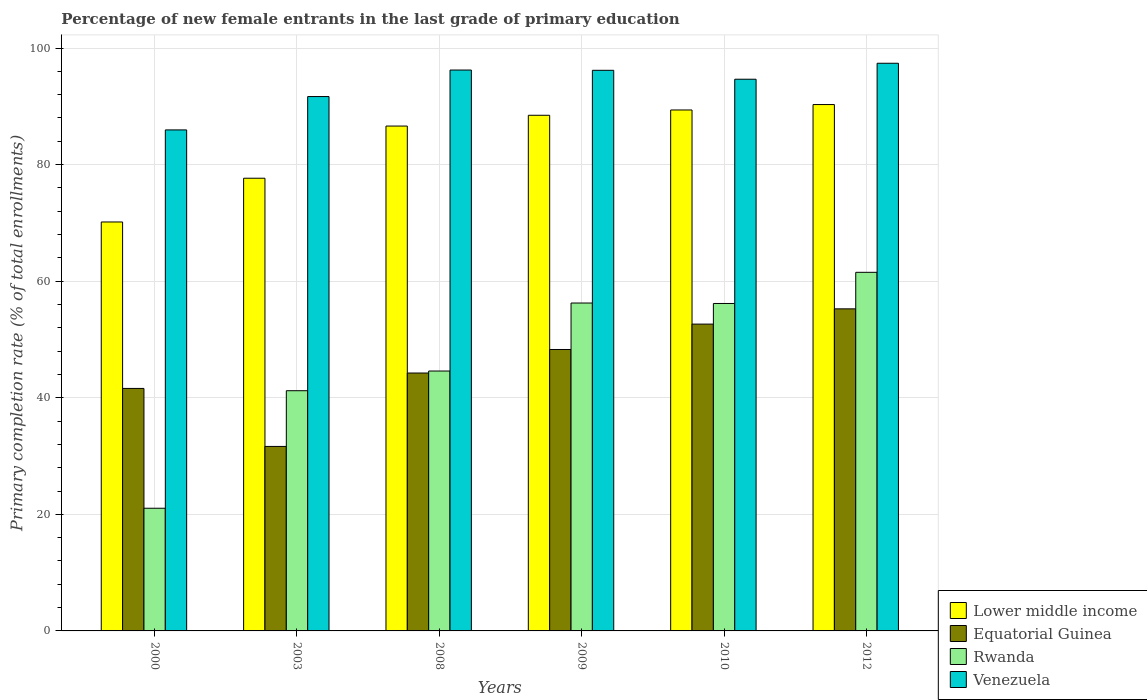How many groups of bars are there?
Offer a very short reply. 6. Are the number of bars on each tick of the X-axis equal?
Your response must be concise. Yes. What is the label of the 6th group of bars from the left?
Keep it short and to the point. 2012. In how many cases, is the number of bars for a given year not equal to the number of legend labels?
Make the answer very short. 0. What is the percentage of new female entrants in Equatorial Guinea in 2008?
Ensure brevity in your answer.  44.24. Across all years, what is the maximum percentage of new female entrants in Venezuela?
Make the answer very short. 97.39. Across all years, what is the minimum percentage of new female entrants in Lower middle income?
Offer a terse response. 70.16. In which year was the percentage of new female entrants in Lower middle income maximum?
Your response must be concise. 2012. In which year was the percentage of new female entrants in Rwanda minimum?
Offer a terse response. 2000. What is the total percentage of new female entrants in Equatorial Guinea in the graph?
Your answer should be very brief. 273.67. What is the difference between the percentage of new female entrants in Rwanda in 2000 and that in 2012?
Give a very brief answer. -40.48. What is the difference between the percentage of new female entrants in Venezuela in 2010 and the percentage of new female entrants in Equatorial Guinea in 2012?
Your answer should be very brief. 39.4. What is the average percentage of new female entrants in Rwanda per year?
Your answer should be very brief. 46.8. In the year 2008, what is the difference between the percentage of new female entrants in Equatorial Guinea and percentage of new female entrants in Lower middle income?
Keep it short and to the point. -42.37. In how many years, is the percentage of new female entrants in Venezuela greater than 80 %?
Provide a short and direct response. 6. What is the ratio of the percentage of new female entrants in Venezuela in 2009 to that in 2012?
Ensure brevity in your answer.  0.99. Is the difference between the percentage of new female entrants in Equatorial Guinea in 2009 and 2012 greater than the difference between the percentage of new female entrants in Lower middle income in 2009 and 2012?
Offer a terse response. No. What is the difference between the highest and the second highest percentage of new female entrants in Equatorial Guinea?
Provide a short and direct response. 2.62. What is the difference between the highest and the lowest percentage of new female entrants in Venezuela?
Make the answer very short. 11.44. In how many years, is the percentage of new female entrants in Venezuela greater than the average percentage of new female entrants in Venezuela taken over all years?
Your answer should be compact. 4. Is the sum of the percentage of new female entrants in Equatorial Guinea in 2008 and 2012 greater than the maximum percentage of new female entrants in Venezuela across all years?
Your answer should be very brief. Yes. What does the 2nd bar from the left in 2009 represents?
Your response must be concise. Equatorial Guinea. What does the 4th bar from the right in 2009 represents?
Offer a very short reply. Lower middle income. How many bars are there?
Provide a short and direct response. 24. Are all the bars in the graph horizontal?
Your answer should be very brief. No. What is the difference between two consecutive major ticks on the Y-axis?
Offer a terse response. 20. Does the graph contain any zero values?
Offer a terse response. No. Where does the legend appear in the graph?
Give a very brief answer. Bottom right. How many legend labels are there?
Offer a very short reply. 4. How are the legend labels stacked?
Offer a very short reply. Vertical. What is the title of the graph?
Your answer should be very brief. Percentage of new female entrants in the last grade of primary education. Does "Burkina Faso" appear as one of the legend labels in the graph?
Provide a short and direct response. No. What is the label or title of the X-axis?
Provide a short and direct response. Years. What is the label or title of the Y-axis?
Your answer should be compact. Primary completion rate (% of total enrollments). What is the Primary completion rate (% of total enrollments) of Lower middle income in 2000?
Keep it short and to the point. 70.16. What is the Primary completion rate (% of total enrollments) in Equatorial Guinea in 2000?
Offer a very short reply. 41.6. What is the Primary completion rate (% of total enrollments) of Rwanda in 2000?
Offer a very short reply. 21.05. What is the Primary completion rate (% of total enrollments) of Venezuela in 2000?
Your response must be concise. 85.95. What is the Primary completion rate (% of total enrollments) in Lower middle income in 2003?
Keep it short and to the point. 77.67. What is the Primary completion rate (% of total enrollments) of Equatorial Guinea in 2003?
Your answer should be compact. 31.65. What is the Primary completion rate (% of total enrollments) of Rwanda in 2003?
Provide a succinct answer. 41.21. What is the Primary completion rate (% of total enrollments) of Venezuela in 2003?
Keep it short and to the point. 91.68. What is the Primary completion rate (% of total enrollments) of Lower middle income in 2008?
Offer a terse response. 86.62. What is the Primary completion rate (% of total enrollments) in Equatorial Guinea in 2008?
Your response must be concise. 44.24. What is the Primary completion rate (% of total enrollments) of Rwanda in 2008?
Ensure brevity in your answer.  44.59. What is the Primary completion rate (% of total enrollments) in Venezuela in 2008?
Offer a terse response. 96.23. What is the Primary completion rate (% of total enrollments) in Lower middle income in 2009?
Offer a very short reply. 88.46. What is the Primary completion rate (% of total enrollments) in Equatorial Guinea in 2009?
Make the answer very short. 48.28. What is the Primary completion rate (% of total enrollments) in Rwanda in 2009?
Keep it short and to the point. 56.25. What is the Primary completion rate (% of total enrollments) of Venezuela in 2009?
Your answer should be compact. 96.18. What is the Primary completion rate (% of total enrollments) in Lower middle income in 2010?
Give a very brief answer. 89.37. What is the Primary completion rate (% of total enrollments) in Equatorial Guinea in 2010?
Keep it short and to the point. 52.64. What is the Primary completion rate (% of total enrollments) in Rwanda in 2010?
Your answer should be compact. 56.18. What is the Primary completion rate (% of total enrollments) in Venezuela in 2010?
Your response must be concise. 94.65. What is the Primary completion rate (% of total enrollments) of Lower middle income in 2012?
Give a very brief answer. 90.3. What is the Primary completion rate (% of total enrollments) in Equatorial Guinea in 2012?
Offer a very short reply. 55.26. What is the Primary completion rate (% of total enrollments) in Rwanda in 2012?
Offer a very short reply. 61.52. What is the Primary completion rate (% of total enrollments) of Venezuela in 2012?
Offer a terse response. 97.39. Across all years, what is the maximum Primary completion rate (% of total enrollments) in Lower middle income?
Provide a succinct answer. 90.3. Across all years, what is the maximum Primary completion rate (% of total enrollments) in Equatorial Guinea?
Provide a succinct answer. 55.26. Across all years, what is the maximum Primary completion rate (% of total enrollments) of Rwanda?
Your answer should be compact. 61.52. Across all years, what is the maximum Primary completion rate (% of total enrollments) of Venezuela?
Make the answer very short. 97.39. Across all years, what is the minimum Primary completion rate (% of total enrollments) in Lower middle income?
Your answer should be very brief. 70.16. Across all years, what is the minimum Primary completion rate (% of total enrollments) of Equatorial Guinea?
Offer a terse response. 31.65. Across all years, what is the minimum Primary completion rate (% of total enrollments) in Rwanda?
Ensure brevity in your answer.  21.05. Across all years, what is the minimum Primary completion rate (% of total enrollments) of Venezuela?
Make the answer very short. 85.95. What is the total Primary completion rate (% of total enrollments) of Lower middle income in the graph?
Offer a very short reply. 502.59. What is the total Primary completion rate (% of total enrollments) in Equatorial Guinea in the graph?
Provide a short and direct response. 273.67. What is the total Primary completion rate (% of total enrollments) in Rwanda in the graph?
Keep it short and to the point. 280.8. What is the total Primary completion rate (% of total enrollments) in Venezuela in the graph?
Give a very brief answer. 562.08. What is the difference between the Primary completion rate (% of total enrollments) of Lower middle income in 2000 and that in 2003?
Ensure brevity in your answer.  -7.51. What is the difference between the Primary completion rate (% of total enrollments) in Equatorial Guinea in 2000 and that in 2003?
Give a very brief answer. 9.95. What is the difference between the Primary completion rate (% of total enrollments) in Rwanda in 2000 and that in 2003?
Offer a very short reply. -20.16. What is the difference between the Primary completion rate (% of total enrollments) of Venezuela in 2000 and that in 2003?
Keep it short and to the point. -5.72. What is the difference between the Primary completion rate (% of total enrollments) of Lower middle income in 2000 and that in 2008?
Provide a short and direct response. -16.46. What is the difference between the Primary completion rate (% of total enrollments) in Equatorial Guinea in 2000 and that in 2008?
Your response must be concise. -2.64. What is the difference between the Primary completion rate (% of total enrollments) of Rwanda in 2000 and that in 2008?
Make the answer very short. -23.54. What is the difference between the Primary completion rate (% of total enrollments) of Venezuela in 2000 and that in 2008?
Keep it short and to the point. -10.27. What is the difference between the Primary completion rate (% of total enrollments) in Lower middle income in 2000 and that in 2009?
Offer a terse response. -18.3. What is the difference between the Primary completion rate (% of total enrollments) in Equatorial Guinea in 2000 and that in 2009?
Offer a terse response. -6.68. What is the difference between the Primary completion rate (% of total enrollments) in Rwanda in 2000 and that in 2009?
Provide a short and direct response. -35.21. What is the difference between the Primary completion rate (% of total enrollments) in Venezuela in 2000 and that in 2009?
Make the answer very short. -10.23. What is the difference between the Primary completion rate (% of total enrollments) of Lower middle income in 2000 and that in 2010?
Keep it short and to the point. -19.21. What is the difference between the Primary completion rate (% of total enrollments) in Equatorial Guinea in 2000 and that in 2010?
Ensure brevity in your answer.  -11.04. What is the difference between the Primary completion rate (% of total enrollments) in Rwanda in 2000 and that in 2010?
Ensure brevity in your answer.  -35.13. What is the difference between the Primary completion rate (% of total enrollments) of Venezuela in 2000 and that in 2010?
Keep it short and to the point. -8.7. What is the difference between the Primary completion rate (% of total enrollments) of Lower middle income in 2000 and that in 2012?
Ensure brevity in your answer.  -20.14. What is the difference between the Primary completion rate (% of total enrollments) of Equatorial Guinea in 2000 and that in 2012?
Ensure brevity in your answer.  -13.65. What is the difference between the Primary completion rate (% of total enrollments) in Rwanda in 2000 and that in 2012?
Provide a short and direct response. -40.48. What is the difference between the Primary completion rate (% of total enrollments) in Venezuela in 2000 and that in 2012?
Make the answer very short. -11.44. What is the difference between the Primary completion rate (% of total enrollments) of Lower middle income in 2003 and that in 2008?
Offer a terse response. -8.95. What is the difference between the Primary completion rate (% of total enrollments) of Equatorial Guinea in 2003 and that in 2008?
Make the answer very short. -12.59. What is the difference between the Primary completion rate (% of total enrollments) of Rwanda in 2003 and that in 2008?
Offer a very short reply. -3.38. What is the difference between the Primary completion rate (% of total enrollments) of Venezuela in 2003 and that in 2008?
Your response must be concise. -4.55. What is the difference between the Primary completion rate (% of total enrollments) in Lower middle income in 2003 and that in 2009?
Provide a short and direct response. -10.8. What is the difference between the Primary completion rate (% of total enrollments) of Equatorial Guinea in 2003 and that in 2009?
Ensure brevity in your answer.  -16.63. What is the difference between the Primary completion rate (% of total enrollments) of Rwanda in 2003 and that in 2009?
Ensure brevity in your answer.  -15.04. What is the difference between the Primary completion rate (% of total enrollments) of Venezuela in 2003 and that in 2009?
Give a very brief answer. -4.51. What is the difference between the Primary completion rate (% of total enrollments) in Lower middle income in 2003 and that in 2010?
Offer a very short reply. -11.71. What is the difference between the Primary completion rate (% of total enrollments) of Equatorial Guinea in 2003 and that in 2010?
Offer a very short reply. -20.99. What is the difference between the Primary completion rate (% of total enrollments) of Rwanda in 2003 and that in 2010?
Provide a short and direct response. -14.97. What is the difference between the Primary completion rate (% of total enrollments) of Venezuela in 2003 and that in 2010?
Provide a succinct answer. -2.98. What is the difference between the Primary completion rate (% of total enrollments) in Lower middle income in 2003 and that in 2012?
Offer a very short reply. -12.64. What is the difference between the Primary completion rate (% of total enrollments) in Equatorial Guinea in 2003 and that in 2012?
Your response must be concise. -23.6. What is the difference between the Primary completion rate (% of total enrollments) of Rwanda in 2003 and that in 2012?
Ensure brevity in your answer.  -20.31. What is the difference between the Primary completion rate (% of total enrollments) of Venezuela in 2003 and that in 2012?
Make the answer very short. -5.71. What is the difference between the Primary completion rate (% of total enrollments) of Lower middle income in 2008 and that in 2009?
Give a very brief answer. -1.85. What is the difference between the Primary completion rate (% of total enrollments) of Equatorial Guinea in 2008 and that in 2009?
Your answer should be very brief. -4.04. What is the difference between the Primary completion rate (% of total enrollments) in Rwanda in 2008 and that in 2009?
Your response must be concise. -11.67. What is the difference between the Primary completion rate (% of total enrollments) in Venezuela in 2008 and that in 2009?
Your answer should be very brief. 0.04. What is the difference between the Primary completion rate (% of total enrollments) of Lower middle income in 2008 and that in 2010?
Offer a terse response. -2.76. What is the difference between the Primary completion rate (% of total enrollments) of Equatorial Guinea in 2008 and that in 2010?
Your answer should be very brief. -8.39. What is the difference between the Primary completion rate (% of total enrollments) in Rwanda in 2008 and that in 2010?
Keep it short and to the point. -11.59. What is the difference between the Primary completion rate (% of total enrollments) of Venezuela in 2008 and that in 2010?
Keep it short and to the point. 1.57. What is the difference between the Primary completion rate (% of total enrollments) of Lower middle income in 2008 and that in 2012?
Provide a short and direct response. -3.69. What is the difference between the Primary completion rate (% of total enrollments) in Equatorial Guinea in 2008 and that in 2012?
Your answer should be compact. -11.01. What is the difference between the Primary completion rate (% of total enrollments) in Rwanda in 2008 and that in 2012?
Give a very brief answer. -16.93. What is the difference between the Primary completion rate (% of total enrollments) of Venezuela in 2008 and that in 2012?
Keep it short and to the point. -1.16. What is the difference between the Primary completion rate (% of total enrollments) of Lower middle income in 2009 and that in 2010?
Give a very brief answer. -0.91. What is the difference between the Primary completion rate (% of total enrollments) in Equatorial Guinea in 2009 and that in 2010?
Offer a very short reply. -4.36. What is the difference between the Primary completion rate (% of total enrollments) in Rwanda in 2009 and that in 2010?
Keep it short and to the point. 0.08. What is the difference between the Primary completion rate (% of total enrollments) in Venezuela in 2009 and that in 2010?
Keep it short and to the point. 1.53. What is the difference between the Primary completion rate (% of total enrollments) of Lower middle income in 2009 and that in 2012?
Give a very brief answer. -1.84. What is the difference between the Primary completion rate (% of total enrollments) in Equatorial Guinea in 2009 and that in 2012?
Give a very brief answer. -6.97. What is the difference between the Primary completion rate (% of total enrollments) in Rwanda in 2009 and that in 2012?
Make the answer very short. -5.27. What is the difference between the Primary completion rate (% of total enrollments) of Venezuela in 2009 and that in 2012?
Offer a terse response. -1.21. What is the difference between the Primary completion rate (% of total enrollments) of Lower middle income in 2010 and that in 2012?
Your answer should be compact. -0.93. What is the difference between the Primary completion rate (% of total enrollments) of Equatorial Guinea in 2010 and that in 2012?
Give a very brief answer. -2.62. What is the difference between the Primary completion rate (% of total enrollments) in Rwanda in 2010 and that in 2012?
Your answer should be compact. -5.35. What is the difference between the Primary completion rate (% of total enrollments) of Venezuela in 2010 and that in 2012?
Make the answer very short. -2.74. What is the difference between the Primary completion rate (% of total enrollments) in Lower middle income in 2000 and the Primary completion rate (% of total enrollments) in Equatorial Guinea in 2003?
Give a very brief answer. 38.51. What is the difference between the Primary completion rate (% of total enrollments) in Lower middle income in 2000 and the Primary completion rate (% of total enrollments) in Rwanda in 2003?
Provide a short and direct response. 28.95. What is the difference between the Primary completion rate (% of total enrollments) in Lower middle income in 2000 and the Primary completion rate (% of total enrollments) in Venezuela in 2003?
Your response must be concise. -21.52. What is the difference between the Primary completion rate (% of total enrollments) in Equatorial Guinea in 2000 and the Primary completion rate (% of total enrollments) in Rwanda in 2003?
Make the answer very short. 0.39. What is the difference between the Primary completion rate (% of total enrollments) of Equatorial Guinea in 2000 and the Primary completion rate (% of total enrollments) of Venezuela in 2003?
Provide a short and direct response. -50.07. What is the difference between the Primary completion rate (% of total enrollments) of Rwanda in 2000 and the Primary completion rate (% of total enrollments) of Venezuela in 2003?
Ensure brevity in your answer.  -70.63. What is the difference between the Primary completion rate (% of total enrollments) of Lower middle income in 2000 and the Primary completion rate (% of total enrollments) of Equatorial Guinea in 2008?
Ensure brevity in your answer.  25.92. What is the difference between the Primary completion rate (% of total enrollments) of Lower middle income in 2000 and the Primary completion rate (% of total enrollments) of Rwanda in 2008?
Your response must be concise. 25.57. What is the difference between the Primary completion rate (% of total enrollments) in Lower middle income in 2000 and the Primary completion rate (% of total enrollments) in Venezuela in 2008?
Make the answer very short. -26.06. What is the difference between the Primary completion rate (% of total enrollments) in Equatorial Guinea in 2000 and the Primary completion rate (% of total enrollments) in Rwanda in 2008?
Keep it short and to the point. -2.99. What is the difference between the Primary completion rate (% of total enrollments) in Equatorial Guinea in 2000 and the Primary completion rate (% of total enrollments) in Venezuela in 2008?
Your answer should be very brief. -54.62. What is the difference between the Primary completion rate (% of total enrollments) in Rwanda in 2000 and the Primary completion rate (% of total enrollments) in Venezuela in 2008?
Offer a terse response. -75.18. What is the difference between the Primary completion rate (% of total enrollments) of Lower middle income in 2000 and the Primary completion rate (% of total enrollments) of Equatorial Guinea in 2009?
Give a very brief answer. 21.88. What is the difference between the Primary completion rate (% of total enrollments) of Lower middle income in 2000 and the Primary completion rate (% of total enrollments) of Rwanda in 2009?
Provide a short and direct response. 13.91. What is the difference between the Primary completion rate (% of total enrollments) in Lower middle income in 2000 and the Primary completion rate (% of total enrollments) in Venezuela in 2009?
Keep it short and to the point. -26.02. What is the difference between the Primary completion rate (% of total enrollments) in Equatorial Guinea in 2000 and the Primary completion rate (% of total enrollments) in Rwanda in 2009?
Provide a succinct answer. -14.65. What is the difference between the Primary completion rate (% of total enrollments) of Equatorial Guinea in 2000 and the Primary completion rate (% of total enrollments) of Venezuela in 2009?
Offer a terse response. -54.58. What is the difference between the Primary completion rate (% of total enrollments) of Rwanda in 2000 and the Primary completion rate (% of total enrollments) of Venezuela in 2009?
Offer a terse response. -75.13. What is the difference between the Primary completion rate (% of total enrollments) in Lower middle income in 2000 and the Primary completion rate (% of total enrollments) in Equatorial Guinea in 2010?
Your response must be concise. 17.52. What is the difference between the Primary completion rate (% of total enrollments) of Lower middle income in 2000 and the Primary completion rate (% of total enrollments) of Rwanda in 2010?
Ensure brevity in your answer.  13.98. What is the difference between the Primary completion rate (% of total enrollments) of Lower middle income in 2000 and the Primary completion rate (% of total enrollments) of Venezuela in 2010?
Offer a very short reply. -24.49. What is the difference between the Primary completion rate (% of total enrollments) in Equatorial Guinea in 2000 and the Primary completion rate (% of total enrollments) in Rwanda in 2010?
Keep it short and to the point. -14.58. What is the difference between the Primary completion rate (% of total enrollments) of Equatorial Guinea in 2000 and the Primary completion rate (% of total enrollments) of Venezuela in 2010?
Your answer should be very brief. -53.05. What is the difference between the Primary completion rate (% of total enrollments) of Rwanda in 2000 and the Primary completion rate (% of total enrollments) of Venezuela in 2010?
Make the answer very short. -73.6. What is the difference between the Primary completion rate (% of total enrollments) of Lower middle income in 2000 and the Primary completion rate (% of total enrollments) of Equatorial Guinea in 2012?
Your answer should be compact. 14.91. What is the difference between the Primary completion rate (% of total enrollments) in Lower middle income in 2000 and the Primary completion rate (% of total enrollments) in Rwanda in 2012?
Give a very brief answer. 8.64. What is the difference between the Primary completion rate (% of total enrollments) in Lower middle income in 2000 and the Primary completion rate (% of total enrollments) in Venezuela in 2012?
Your answer should be compact. -27.23. What is the difference between the Primary completion rate (% of total enrollments) of Equatorial Guinea in 2000 and the Primary completion rate (% of total enrollments) of Rwanda in 2012?
Offer a very short reply. -19.92. What is the difference between the Primary completion rate (% of total enrollments) in Equatorial Guinea in 2000 and the Primary completion rate (% of total enrollments) in Venezuela in 2012?
Offer a very short reply. -55.79. What is the difference between the Primary completion rate (% of total enrollments) of Rwanda in 2000 and the Primary completion rate (% of total enrollments) of Venezuela in 2012?
Your answer should be compact. -76.34. What is the difference between the Primary completion rate (% of total enrollments) of Lower middle income in 2003 and the Primary completion rate (% of total enrollments) of Equatorial Guinea in 2008?
Ensure brevity in your answer.  33.42. What is the difference between the Primary completion rate (% of total enrollments) of Lower middle income in 2003 and the Primary completion rate (% of total enrollments) of Rwanda in 2008?
Offer a terse response. 33.08. What is the difference between the Primary completion rate (% of total enrollments) in Lower middle income in 2003 and the Primary completion rate (% of total enrollments) in Venezuela in 2008?
Offer a very short reply. -18.56. What is the difference between the Primary completion rate (% of total enrollments) in Equatorial Guinea in 2003 and the Primary completion rate (% of total enrollments) in Rwanda in 2008?
Offer a very short reply. -12.94. What is the difference between the Primary completion rate (% of total enrollments) of Equatorial Guinea in 2003 and the Primary completion rate (% of total enrollments) of Venezuela in 2008?
Provide a succinct answer. -64.57. What is the difference between the Primary completion rate (% of total enrollments) in Rwanda in 2003 and the Primary completion rate (% of total enrollments) in Venezuela in 2008?
Ensure brevity in your answer.  -55.02. What is the difference between the Primary completion rate (% of total enrollments) in Lower middle income in 2003 and the Primary completion rate (% of total enrollments) in Equatorial Guinea in 2009?
Your response must be concise. 29.38. What is the difference between the Primary completion rate (% of total enrollments) of Lower middle income in 2003 and the Primary completion rate (% of total enrollments) of Rwanda in 2009?
Make the answer very short. 21.41. What is the difference between the Primary completion rate (% of total enrollments) in Lower middle income in 2003 and the Primary completion rate (% of total enrollments) in Venezuela in 2009?
Give a very brief answer. -18.52. What is the difference between the Primary completion rate (% of total enrollments) of Equatorial Guinea in 2003 and the Primary completion rate (% of total enrollments) of Rwanda in 2009?
Keep it short and to the point. -24.6. What is the difference between the Primary completion rate (% of total enrollments) in Equatorial Guinea in 2003 and the Primary completion rate (% of total enrollments) in Venezuela in 2009?
Give a very brief answer. -64.53. What is the difference between the Primary completion rate (% of total enrollments) in Rwanda in 2003 and the Primary completion rate (% of total enrollments) in Venezuela in 2009?
Offer a very short reply. -54.97. What is the difference between the Primary completion rate (% of total enrollments) of Lower middle income in 2003 and the Primary completion rate (% of total enrollments) of Equatorial Guinea in 2010?
Offer a terse response. 25.03. What is the difference between the Primary completion rate (% of total enrollments) of Lower middle income in 2003 and the Primary completion rate (% of total enrollments) of Rwanda in 2010?
Provide a short and direct response. 21.49. What is the difference between the Primary completion rate (% of total enrollments) in Lower middle income in 2003 and the Primary completion rate (% of total enrollments) in Venezuela in 2010?
Provide a short and direct response. -16.99. What is the difference between the Primary completion rate (% of total enrollments) of Equatorial Guinea in 2003 and the Primary completion rate (% of total enrollments) of Rwanda in 2010?
Provide a short and direct response. -24.53. What is the difference between the Primary completion rate (% of total enrollments) of Equatorial Guinea in 2003 and the Primary completion rate (% of total enrollments) of Venezuela in 2010?
Your response must be concise. -63. What is the difference between the Primary completion rate (% of total enrollments) in Rwanda in 2003 and the Primary completion rate (% of total enrollments) in Venezuela in 2010?
Give a very brief answer. -53.44. What is the difference between the Primary completion rate (% of total enrollments) in Lower middle income in 2003 and the Primary completion rate (% of total enrollments) in Equatorial Guinea in 2012?
Your answer should be very brief. 22.41. What is the difference between the Primary completion rate (% of total enrollments) in Lower middle income in 2003 and the Primary completion rate (% of total enrollments) in Rwanda in 2012?
Give a very brief answer. 16.14. What is the difference between the Primary completion rate (% of total enrollments) of Lower middle income in 2003 and the Primary completion rate (% of total enrollments) of Venezuela in 2012?
Offer a very short reply. -19.72. What is the difference between the Primary completion rate (% of total enrollments) in Equatorial Guinea in 2003 and the Primary completion rate (% of total enrollments) in Rwanda in 2012?
Your answer should be compact. -29.87. What is the difference between the Primary completion rate (% of total enrollments) of Equatorial Guinea in 2003 and the Primary completion rate (% of total enrollments) of Venezuela in 2012?
Make the answer very short. -65.74. What is the difference between the Primary completion rate (% of total enrollments) of Rwanda in 2003 and the Primary completion rate (% of total enrollments) of Venezuela in 2012?
Give a very brief answer. -56.18. What is the difference between the Primary completion rate (% of total enrollments) of Lower middle income in 2008 and the Primary completion rate (% of total enrollments) of Equatorial Guinea in 2009?
Provide a short and direct response. 38.34. What is the difference between the Primary completion rate (% of total enrollments) in Lower middle income in 2008 and the Primary completion rate (% of total enrollments) in Rwanda in 2009?
Your answer should be compact. 30.36. What is the difference between the Primary completion rate (% of total enrollments) of Lower middle income in 2008 and the Primary completion rate (% of total enrollments) of Venezuela in 2009?
Keep it short and to the point. -9.56. What is the difference between the Primary completion rate (% of total enrollments) in Equatorial Guinea in 2008 and the Primary completion rate (% of total enrollments) in Rwanda in 2009?
Make the answer very short. -12.01. What is the difference between the Primary completion rate (% of total enrollments) of Equatorial Guinea in 2008 and the Primary completion rate (% of total enrollments) of Venezuela in 2009?
Provide a short and direct response. -51.94. What is the difference between the Primary completion rate (% of total enrollments) of Rwanda in 2008 and the Primary completion rate (% of total enrollments) of Venezuela in 2009?
Your response must be concise. -51.59. What is the difference between the Primary completion rate (% of total enrollments) of Lower middle income in 2008 and the Primary completion rate (% of total enrollments) of Equatorial Guinea in 2010?
Your answer should be very brief. 33.98. What is the difference between the Primary completion rate (% of total enrollments) in Lower middle income in 2008 and the Primary completion rate (% of total enrollments) in Rwanda in 2010?
Your answer should be very brief. 30.44. What is the difference between the Primary completion rate (% of total enrollments) of Lower middle income in 2008 and the Primary completion rate (% of total enrollments) of Venezuela in 2010?
Make the answer very short. -8.03. What is the difference between the Primary completion rate (% of total enrollments) in Equatorial Guinea in 2008 and the Primary completion rate (% of total enrollments) in Rwanda in 2010?
Your answer should be compact. -11.93. What is the difference between the Primary completion rate (% of total enrollments) in Equatorial Guinea in 2008 and the Primary completion rate (% of total enrollments) in Venezuela in 2010?
Keep it short and to the point. -50.41. What is the difference between the Primary completion rate (% of total enrollments) in Rwanda in 2008 and the Primary completion rate (% of total enrollments) in Venezuela in 2010?
Give a very brief answer. -50.06. What is the difference between the Primary completion rate (% of total enrollments) in Lower middle income in 2008 and the Primary completion rate (% of total enrollments) in Equatorial Guinea in 2012?
Provide a short and direct response. 31.36. What is the difference between the Primary completion rate (% of total enrollments) of Lower middle income in 2008 and the Primary completion rate (% of total enrollments) of Rwanda in 2012?
Ensure brevity in your answer.  25.09. What is the difference between the Primary completion rate (% of total enrollments) in Lower middle income in 2008 and the Primary completion rate (% of total enrollments) in Venezuela in 2012?
Offer a very short reply. -10.77. What is the difference between the Primary completion rate (% of total enrollments) of Equatorial Guinea in 2008 and the Primary completion rate (% of total enrollments) of Rwanda in 2012?
Your answer should be very brief. -17.28. What is the difference between the Primary completion rate (% of total enrollments) of Equatorial Guinea in 2008 and the Primary completion rate (% of total enrollments) of Venezuela in 2012?
Provide a succinct answer. -53.14. What is the difference between the Primary completion rate (% of total enrollments) of Rwanda in 2008 and the Primary completion rate (% of total enrollments) of Venezuela in 2012?
Make the answer very short. -52.8. What is the difference between the Primary completion rate (% of total enrollments) in Lower middle income in 2009 and the Primary completion rate (% of total enrollments) in Equatorial Guinea in 2010?
Offer a terse response. 35.83. What is the difference between the Primary completion rate (% of total enrollments) in Lower middle income in 2009 and the Primary completion rate (% of total enrollments) in Rwanda in 2010?
Keep it short and to the point. 32.29. What is the difference between the Primary completion rate (% of total enrollments) in Lower middle income in 2009 and the Primary completion rate (% of total enrollments) in Venezuela in 2010?
Keep it short and to the point. -6.19. What is the difference between the Primary completion rate (% of total enrollments) in Equatorial Guinea in 2009 and the Primary completion rate (% of total enrollments) in Rwanda in 2010?
Offer a very short reply. -7.9. What is the difference between the Primary completion rate (% of total enrollments) of Equatorial Guinea in 2009 and the Primary completion rate (% of total enrollments) of Venezuela in 2010?
Ensure brevity in your answer.  -46.37. What is the difference between the Primary completion rate (% of total enrollments) in Rwanda in 2009 and the Primary completion rate (% of total enrollments) in Venezuela in 2010?
Provide a short and direct response. -38.4. What is the difference between the Primary completion rate (% of total enrollments) in Lower middle income in 2009 and the Primary completion rate (% of total enrollments) in Equatorial Guinea in 2012?
Offer a terse response. 33.21. What is the difference between the Primary completion rate (% of total enrollments) of Lower middle income in 2009 and the Primary completion rate (% of total enrollments) of Rwanda in 2012?
Provide a succinct answer. 26.94. What is the difference between the Primary completion rate (% of total enrollments) in Lower middle income in 2009 and the Primary completion rate (% of total enrollments) in Venezuela in 2012?
Make the answer very short. -8.92. What is the difference between the Primary completion rate (% of total enrollments) in Equatorial Guinea in 2009 and the Primary completion rate (% of total enrollments) in Rwanda in 2012?
Your response must be concise. -13.24. What is the difference between the Primary completion rate (% of total enrollments) of Equatorial Guinea in 2009 and the Primary completion rate (% of total enrollments) of Venezuela in 2012?
Keep it short and to the point. -49.11. What is the difference between the Primary completion rate (% of total enrollments) in Rwanda in 2009 and the Primary completion rate (% of total enrollments) in Venezuela in 2012?
Keep it short and to the point. -41.13. What is the difference between the Primary completion rate (% of total enrollments) of Lower middle income in 2010 and the Primary completion rate (% of total enrollments) of Equatorial Guinea in 2012?
Make the answer very short. 34.12. What is the difference between the Primary completion rate (% of total enrollments) of Lower middle income in 2010 and the Primary completion rate (% of total enrollments) of Rwanda in 2012?
Ensure brevity in your answer.  27.85. What is the difference between the Primary completion rate (% of total enrollments) of Lower middle income in 2010 and the Primary completion rate (% of total enrollments) of Venezuela in 2012?
Provide a succinct answer. -8.01. What is the difference between the Primary completion rate (% of total enrollments) of Equatorial Guinea in 2010 and the Primary completion rate (% of total enrollments) of Rwanda in 2012?
Your answer should be compact. -8.89. What is the difference between the Primary completion rate (% of total enrollments) of Equatorial Guinea in 2010 and the Primary completion rate (% of total enrollments) of Venezuela in 2012?
Make the answer very short. -44.75. What is the difference between the Primary completion rate (% of total enrollments) in Rwanda in 2010 and the Primary completion rate (% of total enrollments) in Venezuela in 2012?
Make the answer very short. -41.21. What is the average Primary completion rate (% of total enrollments) in Lower middle income per year?
Ensure brevity in your answer.  83.76. What is the average Primary completion rate (% of total enrollments) in Equatorial Guinea per year?
Offer a very short reply. 45.61. What is the average Primary completion rate (% of total enrollments) in Rwanda per year?
Provide a short and direct response. 46.8. What is the average Primary completion rate (% of total enrollments) in Venezuela per year?
Your answer should be compact. 93.68. In the year 2000, what is the difference between the Primary completion rate (% of total enrollments) of Lower middle income and Primary completion rate (% of total enrollments) of Equatorial Guinea?
Provide a succinct answer. 28.56. In the year 2000, what is the difference between the Primary completion rate (% of total enrollments) of Lower middle income and Primary completion rate (% of total enrollments) of Rwanda?
Offer a very short reply. 49.11. In the year 2000, what is the difference between the Primary completion rate (% of total enrollments) of Lower middle income and Primary completion rate (% of total enrollments) of Venezuela?
Your response must be concise. -15.79. In the year 2000, what is the difference between the Primary completion rate (% of total enrollments) in Equatorial Guinea and Primary completion rate (% of total enrollments) in Rwanda?
Your answer should be very brief. 20.55. In the year 2000, what is the difference between the Primary completion rate (% of total enrollments) of Equatorial Guinea and Primary completion rate (% of total enrollments) of Venezuela?
Provide a succinct answer. -44.35. In the year 2000, what is the difference between the Primary completion rate (% of total enrollments) of Rwanda and Primary completion rate (% of total enrollments) of Venezuela?
Keep it short and to the point. -64.91. In the year 2003, what is the difference between the Primary completion rate (% of total enrollments) of Lower middle income and Primary completion rate (% of total enrollments) of Equatorial Guinea?
Your response must be concise. 46.01. In the year 2003, what is the difference between the Primary completion rate (% of total enrollments) in Lower middle income and Primary completion rate (% of total enrollments) in Rwanda?
Give a very brief answer. 36.46. In the year 2003, what is the difference between the Primary completion rate (% of total enrollments) in Lower middle income and Primary completion rate (% of total enrollments) in Venezuela?
Your answer should be compact. -14.01. In the year 2003, what is the difference between the Primary completion rate (% of total enrollments) in Equatorial Guinea and Primary completion rate (% of total enrollments) in Rwanda?
Your answer should be very brief. -9.56. In the year 2003, what is the difference between the Primary completion rate (% of total enrollments) in Equatorial Guinea and Primary completion rate (% of total enrollments) in Venezuela?
Give a very brief answer. -60.02. In the year 2003, what is the difference between the Primary completion rate (% of total enrollments) of Rwanda and Primary completion rate (% of total enrollments) of Venezuela?
Make the answer very short. -50.47. In the year 2008, what is the difference between the Primary completion rate (% of total enrollments) of Lower middle income and Primary completion rate (% of total enrollments) of Equatorial Guinea?
Your answer should be compact. 42.37. In the year 2008, what is the difference between the Primary completion rate (% of total enrollments) of Lower middle income and Primary completion rate (% of total enrollments) of Rwanda?
Your answer should be very brief. 42.03. In the year 2008, what is the difference between the Primary completion rate (% of total enrollments) of Lower middle income and Primary completion rate (% of total enrollments) of Venezuela?
Provide a short and direct response. -9.61. In the year 2008, what is the difference between the Primary completion rate (% of total enrollments) of Equatorial Guinea and Primary completion rate (% of total enrollments) of Rwanda?
Give a very brief answer. -0.34. In the year 2008, what is the difference between the Primary completion rate (% of total enrollments) of Equatorial Guinea and Primary completion rate (% of total enrollments) of Venezuela?
Your answer should be compact. -51.98. In the year 2008, what is the difference between the Primary completion rate (% of total enrollments) in Rwanda and Primary completion rate (% of total enrollments) in Venezuela?
Provide a succinct answer. -51.64. In the year 2009, what is the difference between the Primary completion rate (% of total enrollments) in Lower middle income and Primary completion rate (% of total enrollments) in Equatorial Guinea?
Give a very brief answer. 40.18. In the year 2009, what is the difference between the Primary completion rate (% of total enrollments) of Lower middle income and Primary completion rate (% of total enrollments) of Rwanda?
Your answer should be compact. 32.21. In the year 2009, what is the difference between the Primary completion rate (% of total enrollments) of Lower middle income and Primary completion rate (% of total enrollments) of Venezuela?
Keep it short and to the point. -7.72. In the year 2009, what is the difference between the Primary completion rate (% of total enrollments) of Equatorial Guinea and Primary completion rate (% of total enrollments) of Rwanda?
Offer a terse response. -7.97. In the year 2009, what is the difference between the Primary completion rate (% of total enrollments) in Equatorial Guinea and Primary completion rate (% of total enrollments) in Venezuela?
Make the answer very short. -47.9. In the year 2009, what is the difference between the Primary completion rate (% of total enrollments) in Rwanda and Primary completion rate (% of total enrollments) in Venezuela?
Your answer should be very brief. -39.93. In the year 2010, what is the difference between the Primary completion rate (% of total enrollments) in Lower middle income and Primary completion rate (% of total enrollments) in Equatorial Guinea?
Offer a very short reply. 36.74. In the year 2010, what is the difference between the Primary completion rate (% of total enrollments) in Lower middle income and Primary completion rate (% of total enrollments) in Rwanda?
Offer a terse response. 33.2. In the year 2010, what is the difference between the Primary completion rate (% of total enrollments) in Lower middle income and Primary completion rate (% of total enrollments) in Venezuela?
Offer a very short reply. -5.28. In the year 2010, what is the difference between the Primary completion rate (% of total enrollments) of Equatorial Guinea and Primary completion rate (% of total enrollments) of Rwanda?
Give a very brief answer. -3.54. In the year 2010, what is the difference between the Primary completion rate (% of total enrollments) of Equatorial Guinea and Primary completion rate (% of total enrollments) of Venezuela?
Keep it short and to the point. -42.01. In the year 2010, what is the difference between the Primary completion rate (% of total enrollments) in Rwanda and Primary completion rate (% of total enrollments) in Venezuela?
Give a very brief answer. -38.47. In the year 2012, what is the difference between the Primary completion rate (% of total enrollments) in Lower middle income and Primary completion rate (% of total enrollments) in Equatorial Guinea?
Offer a terse response. 35.05. In the year 2012, what is the difference between the Primary completion rate (% of total enrollments) in Lower middle income and Primary completion rate (% of total enrollments) in Rwanda?
Provide a succinct answer. 28.78. In the year 2012, what is the difference between the Primary completion rate (% of total enrollments) in Lower middle income and Primary completion rate (% of total enrollments) in Venezuela?
Your answer should be very brief. -7.08. In the year 2012, what is the difference between the Primary completion rate (% of total enrollments) in Equatorial Guinea and Primary completion rate (% of total enrollments) in Rwanda?
Offer a terse response. -6.27. In the year 2012, what is the difference between the Primary completion rate (% of total enrollments) in Equatorial Guinea and Primary completion rate (% of total enrollments) in Venezuela?
Ensure brevity in your answer.  -42.13. In the year 2012, what is the difference between the Primary completion rate (% of total enrollments) of Rwanda and Primary completion rate (% of total enrollments) of Venezuela?
Offer a very short reply. -35.87. What is the ratio of the Primary completion rate (% of total enrollments) of Lower middle income in 2000 to that in 2003?
Ensure brevity in your answer.  0.9. What is the ratio of the Primary completion rate (% of total enrollments) of Equatorial Guinea in 2000 to that in 2003?
Your answer should be compact. 1.31. What is the ratio of the Primary completion rate (% of total enrollments) of Rwanda in 2000 to that in 2003?
Your answer should be very brief. 0.51. What is the ratio of the Primary completion rate (% of total enrollments) of Venezuela in 2000 to that in 2003?
Provide a succinct answer. 0.94. What is the ratio of the Primary completion rate (% of total enrollments) in Lower middle income in 2000 to that in 2008?
Offer a very short reply. 0.81. What is the ratio of the Primary completion rate (% of total enrollments) in Equatorial Guinea in 2000 to that in 2008?
Ensure brevity in your answer.  0.94. What is the ratio of the Primary completion rate (% of total enrollments) of Rwanda in 2000 to that in 2008?
Offer a terse response. 0.47. What is the ratio of the Primary completion rate (% of total enrollments) in Venezuela in 2000 to that in 2008?
Offer a terse response. 0.89. What is the ratio of the Primary completion rate (% of total enrollments) in Lower middle income in 2000 to that in 2009?
Offer a terse response. 0.79. What is the ratio of the Primary completion rate (% of total enrollments) of Equatorial Guinea in 2000 to that in 2009?
Provide a short and direct response. 0.86. What is the ratio of the Primary completion rate (% of total enrollments) of Rwanda in 2000 to that in 2009?
Your answer should be very brief. 0.37. What is the ratio of the Primary completion rate (% of total enrollments) in Venezuela in 2000 to that in 2009?
Ensure brevity in your answer.  0.89. What is the ratio of the Primary completion rate (% of total enrollments) in Lower middle income in 2000 to that in 2010?
Your answer should be very brief. 0.79. What is the ratio of the Primary completion rate (% of total enrollments) of Equatorial Guinea in 2000 to that in 2010?
Offer a very short reply. 0.79. What is the ratio of the Primary completion rate (% of total enrollments) of Rwanda in 2000 to that in 2010?
Provide a short and direct response. 0.37. What is the ratio of the Primary completion rate (% of total enrollments) in Venezuela in 2000 to that in 2010?
Provide a succinct answer. 0.91. What is the ratio of the Primary completion rate (% of total enrollments) in Lower middle income in 2000 to that in 2012?
Provide a succinct answer. 0.78. What is the ratio of the Primary completion rate (% of total enrollments) of Equatorial Guinea in 2000 to that in 2012?
Your response must be concise. 0.75. What is the ratio of the Primary completion rate (% of total enrollments) in Rwanda in 2000 to that in 2012?
Your answer should be compact. 0.34. What is the ratio of the Primary completion rate (% of total enrollments) in Venezuela in 2000 to that in 2012?
Give a very brief answer. 0.88. What is the ratio of the Primary completion rate (% of total enrollments) of Lower middle income in 2003 to that in 2008?
Your answer should be compact. 0.9. What is the ratio of the Primary completion rate (% of total enrollments) in Equatorial Guinea in 2003 to that in 2008?
Provide a succinct answer. 0.72. What is the ratio of the Primary completion rate (% of total enrollments) in Rwanda in 2003 to that in 2008?
Keep it short and to the point. 0.92. What is the ratio of the Primary completion rate (% of total enrollments) of Venezuela in 2003 to that in 2008?
Your answer should be compact. 0.95. What is the ratio of the Primary completion rate (% of total enrollments) in Lower middle income in 2003 to that in 2009?
Provide a succinct answer. 0.88. What is the ratio of the Primary completion rate (% of total enrollments) in Equatorial Guinea in 2003 to that in 2009?
Your response must be concise. 0.66. What is the ratio of the Primary completion rate (% of total enrollments) of Rwanda in 2003 to that in 2009?
Your response must be concise. 0.73. What is the ratio of the Primary completion rate (% of total enrollments) in Venezuela in 2003 to that in 2009?
Offer a terse response. 0.95. What is the ratio of the Primary completion rate (% of total enrollments) of Lower middle income in 2003 to that in 2010?
Provide a short and direct response. 0.87. What is the ratio of the Primary completion rate (% of total enrollments) of Equatorial Guinea in 2003 to that in 2010?
Your answer should be compact. 0.6. What is the ratio of the Primary completion rate (% of total enrollments) of Rwanda in 2003 to that in 2010?
Provide a succinct answer. 0.73. What is the ratio of the Primary completion rate (% of total enrollments) in Venezuela in 2003 to that in 2010?
Offer a terse response. 0.97. What is the ratio of the Primary completion rate (% of total enrollments) of Lower middle income in 2003 to that in 2012?
Offer a terse response. 0.86. What is the ratio of the Primary completion rate (% of total enrollments) of Equatorial Guinea in 2003 to that in 2012?
Ensure brevity in your answer.  0.57. What is the ratio of the Primary completion rate (% of total enrollments) of Rwanda in 2003 to that in 2012?
Offer a terse response. 0.67. What is the ratio of the Primary completion rate (% of total enrollments) of Venezuela in 2003 to that in 2012?
Your answer should be compact. 0.94. What is the ratio of the Primary completion rate (% of total enrollments) of Lower middle income in 2008 to that in 2009?
Give a very brief answer. 0.98. What is the ratio of the Primary completion rate (% of total enrollments) in Equatorial Guinea in 2008 to that in 2009?
Provide a short and direct response. 0.92. What is the ratio of the Primary completion rate (% of total enrollments) in Rwanda in 2008 to that in 2009?
Provide a short and direct response. 0.79. What is the ratio of the Primary completion rate (% of total enrollments) in Lower middle income in 2008 to that in 2010?
Give a very brief answer. 0.97. What is the ratio of the Primary completion rate (% of total enrollments) in Equatorial Guinea in 2008 to that in 2010?
Offer a very short reply. 0.84. What is the ratio of the Primary completion rate (% of total enrollments) in Rwanda in 2008 to that in 2010?
Offer a terse response. 0.79. What is the ratio of the Primary completion rate (% of total enrollments) in Venezuela in 2008 to that in 2010?
Offer a very short reply. 1.02. What is the ratio of the Primary completion rate (% of total enrollments) in Lower middle income in 2008 to that in 2012?
Provide a short and direct response. 0.96. What is the ratio of the Primary completion rate (% of total enrollments) in Equatorial Guinea in 2008 to that in 2012?
Provide a succinct answer. 0.8. What is the ratio of the Primary completion rate (% of total enrollments) of Rwanda in 2008 to that in 2012?
Your answer should be very brief. 0.72. What is the ratio of the Primary completion rate (% of total enrollments) of Venezuela in 2008 to that in 2012?
Provide a succinct answer. 0.99. What is the ratio of the Primary completion rate (% of total enrollments) in Lower middle income in 2009 to that in 2010?
Your answer should be compact. 0.99. What is the ratio of the Primary completion rate (% of total enrollments) in Equatorial Guinea in 2009 to that in 2010?
Offer a terse response. 0.92. What is the ratio of the Primary completion rate (% of total enrollments) in Venezuela in 2009 to that in 2010?
Make the answer very short. 1.02. What is the ratio of the Primary completion rate (% of total enrollments) of Lower middle income in 2009 to that in 2012?
Make the answer very short. 0.98. What is the ratio of the Primary completion rate (% of total enrollments) of Equatorial Guinea in 2009 to that in 2012?
Offer a terse response. 0.87. What is the ratio of the Primary completion rate (% of total enrollments) of Rwanda in 2009 to that in 2012?
Provide a succinct answer. 0.91. What is the ratio of the Primary completion rate (% of total enrollments) in Venezuela in 2009 to that in 2012?
Provide a succinct answer. 0.99. What is the ratio of the Primary completion rate (% of total enrollments) of Lower middle income in 2010 to that in 2012?
Your answer should be compact. 0.99. What is the ratio of the Primary completion rate (% of total enrollments) in Equatorial Guinea in 2010 to that in 2012?
Your answer should be compact. 0.95. What is the ratio of the Primary completion rate (% of total enrollments) in Rwanda in 2010 to that in 2012?
Your answer should be very brief. 0.91. What is the ratio of the Primary completion rate (% of total enrollments) of Venezuela in 2010 to that in 2012?
Your answer should be very brief. 0.97. What is the difference between the highest and the second highest Primary completion rate (% of total enrollments) in Lower middle income?
Offer a very short reply. 0.93. What is the difference between the highest and the second highest Primary completion rate (% of total enrollments) in Equatorial Guinea?
Ensure brevity in your answer.  2.62. What is the difference between the highest and the second highest Primary completion rate (% of total enrollments) of Rwanda?
Your response must be concise. 5.27. What is the difference between the highest and the second highest Primary completion rate (% of total enrollments) in Venezuela?
Provide a succinct answer. 1.16. What is the difference between the highest and the lowest Primary completion rate (% of total enrollments) in Lower middle income?
Ensure brevity in your answer.  20.14. What is the difference between the highest and the lowest Primary completion rate (% of total enrollments) in Equatorial Guinea?
Your response must be concise. 23.6. What is the difference between the highest and the lowest Primary completion rate (% of total enrollments) of Rwanda?
Make the answer very short. 40.48. What is the difference between the highest and the lowest Primary completion rate (% of total enrollments) of Venezuela?
Ensure brevity in your answer.  11.44. 